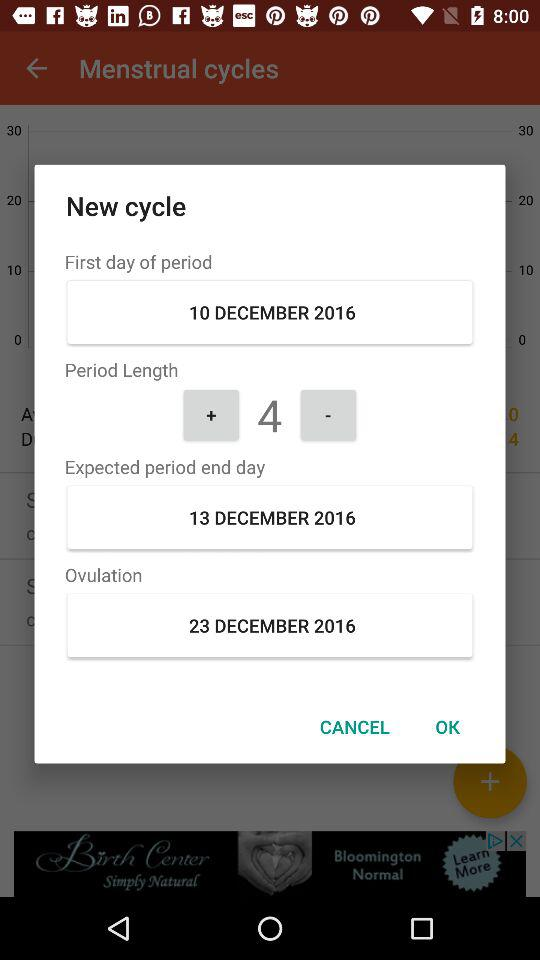How old is the user?
When the provided information is insufficient, respond with <no answer>. <no answer> 